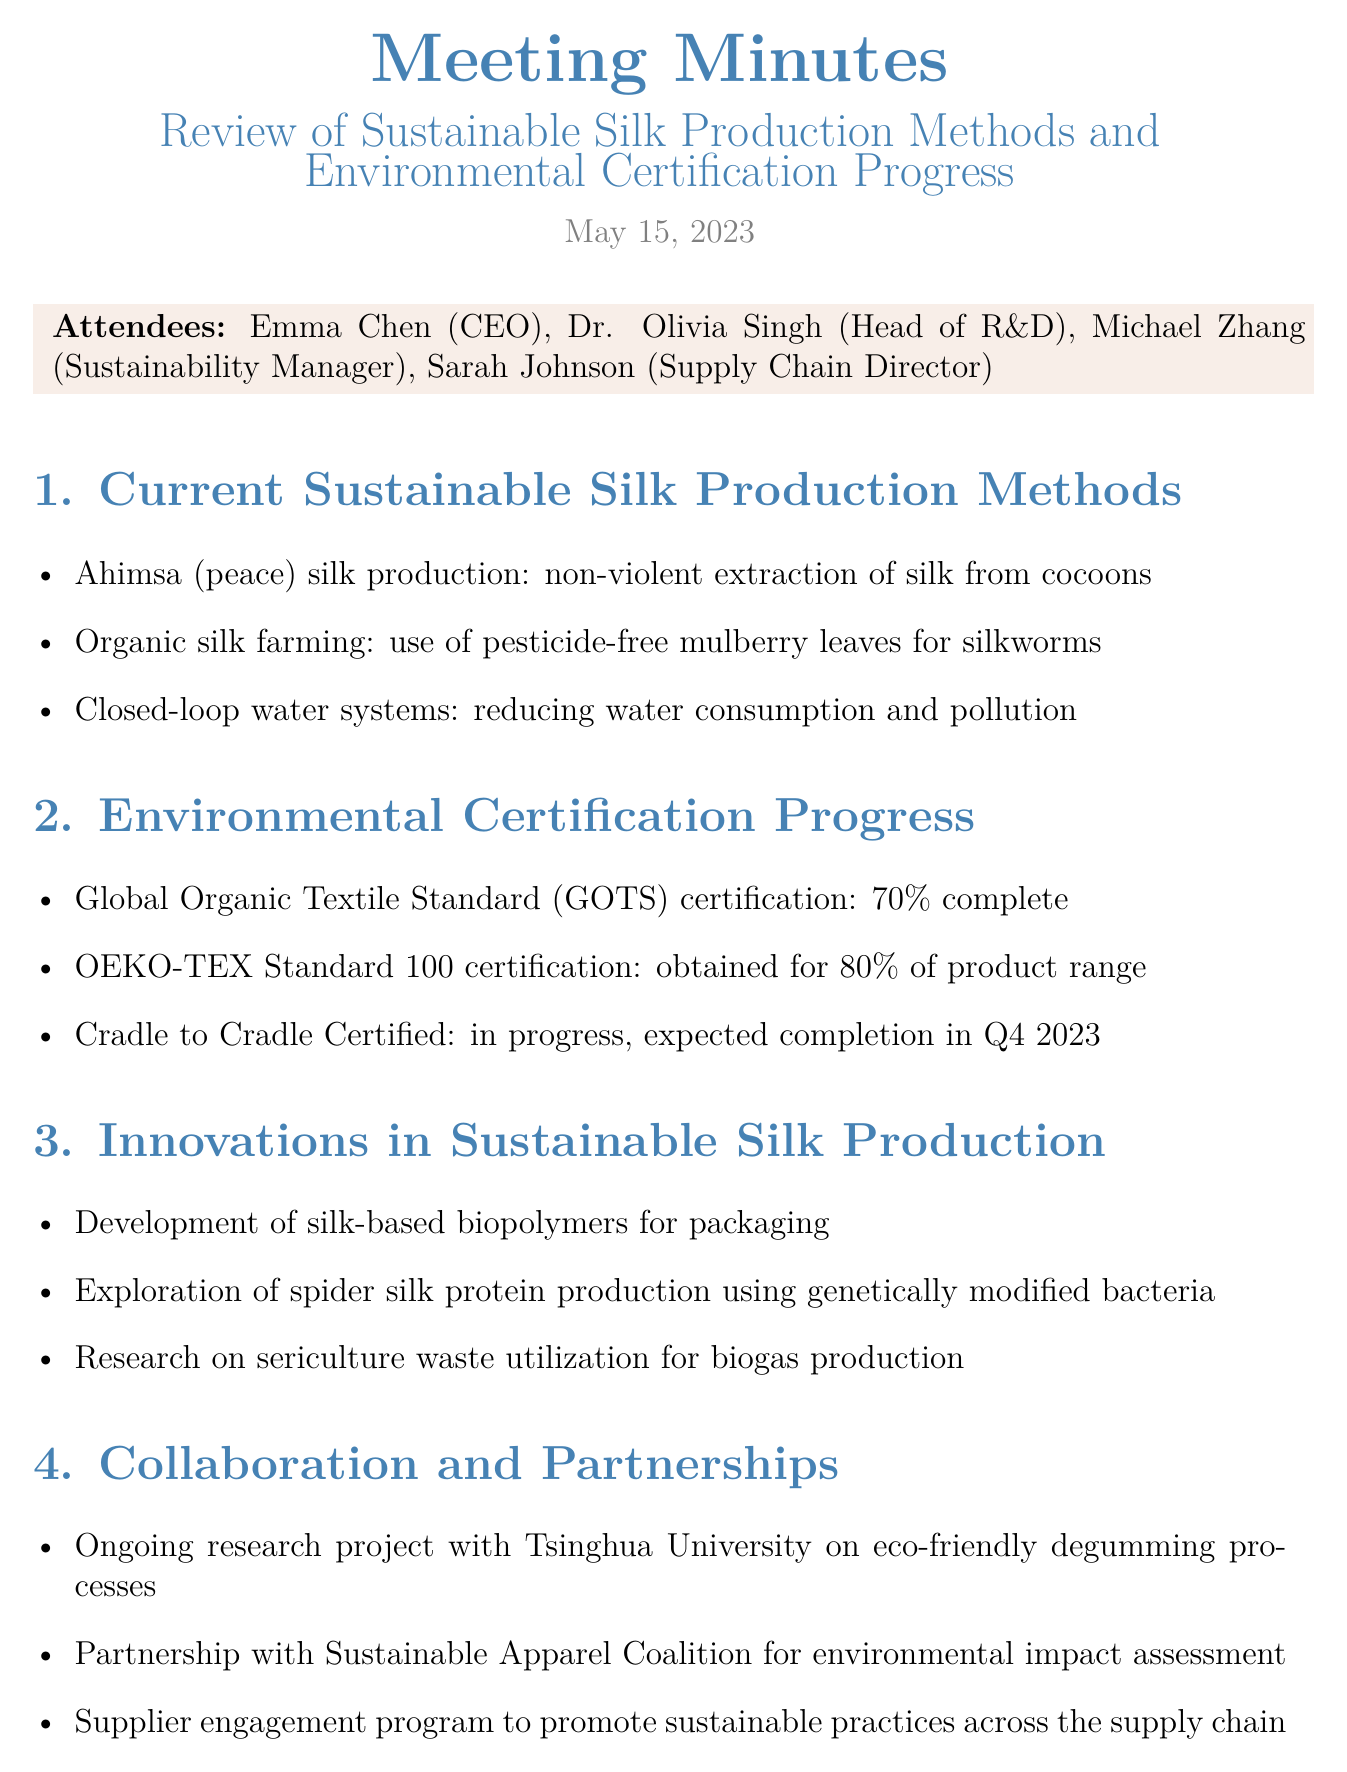What is the date of the meeting? The date of the meeting is mentioned at the beginning of the document.
Answer: May 15, 2023 Who is the Head of Research & Development? The document lists the attendees, including their positions.
Answer: Dr. Olivia Singh What percentage of the Global Organic Textile Standard certification is complete? This information is found under the Environmental Certification Progress section.
Answer: 70 percent Which certification has been obtained for 80% of the product range? The certifications are detailed in the Environmental Certification Progress section.
Answer: OEKO-TEX Standard 100 What is one innovation mentioned in the document? Innovations are listed under a specific section in the document.
Answer: Development of silk-based biopolymers for packaging By how much does the company plan to expand organic silk production capacity? The plan for capacity expansion is stated in the Next Steps section.
Answer: 30 percent What is a partnership mentioned in the document? Collaboration and Partnerships section outlines various partnerships.
Answer: Partnership with Sustainable Apparel Coalition When is the expected completion for Cradle to Cradle Certified? The timeline for certification progress is detailed in the document.
Answer: Q4 2023 What project is ongoing with Tsinghua University? The collaboration details include the project focus in the Partnerships section.
Answer: Eco-friendly degumming processes 